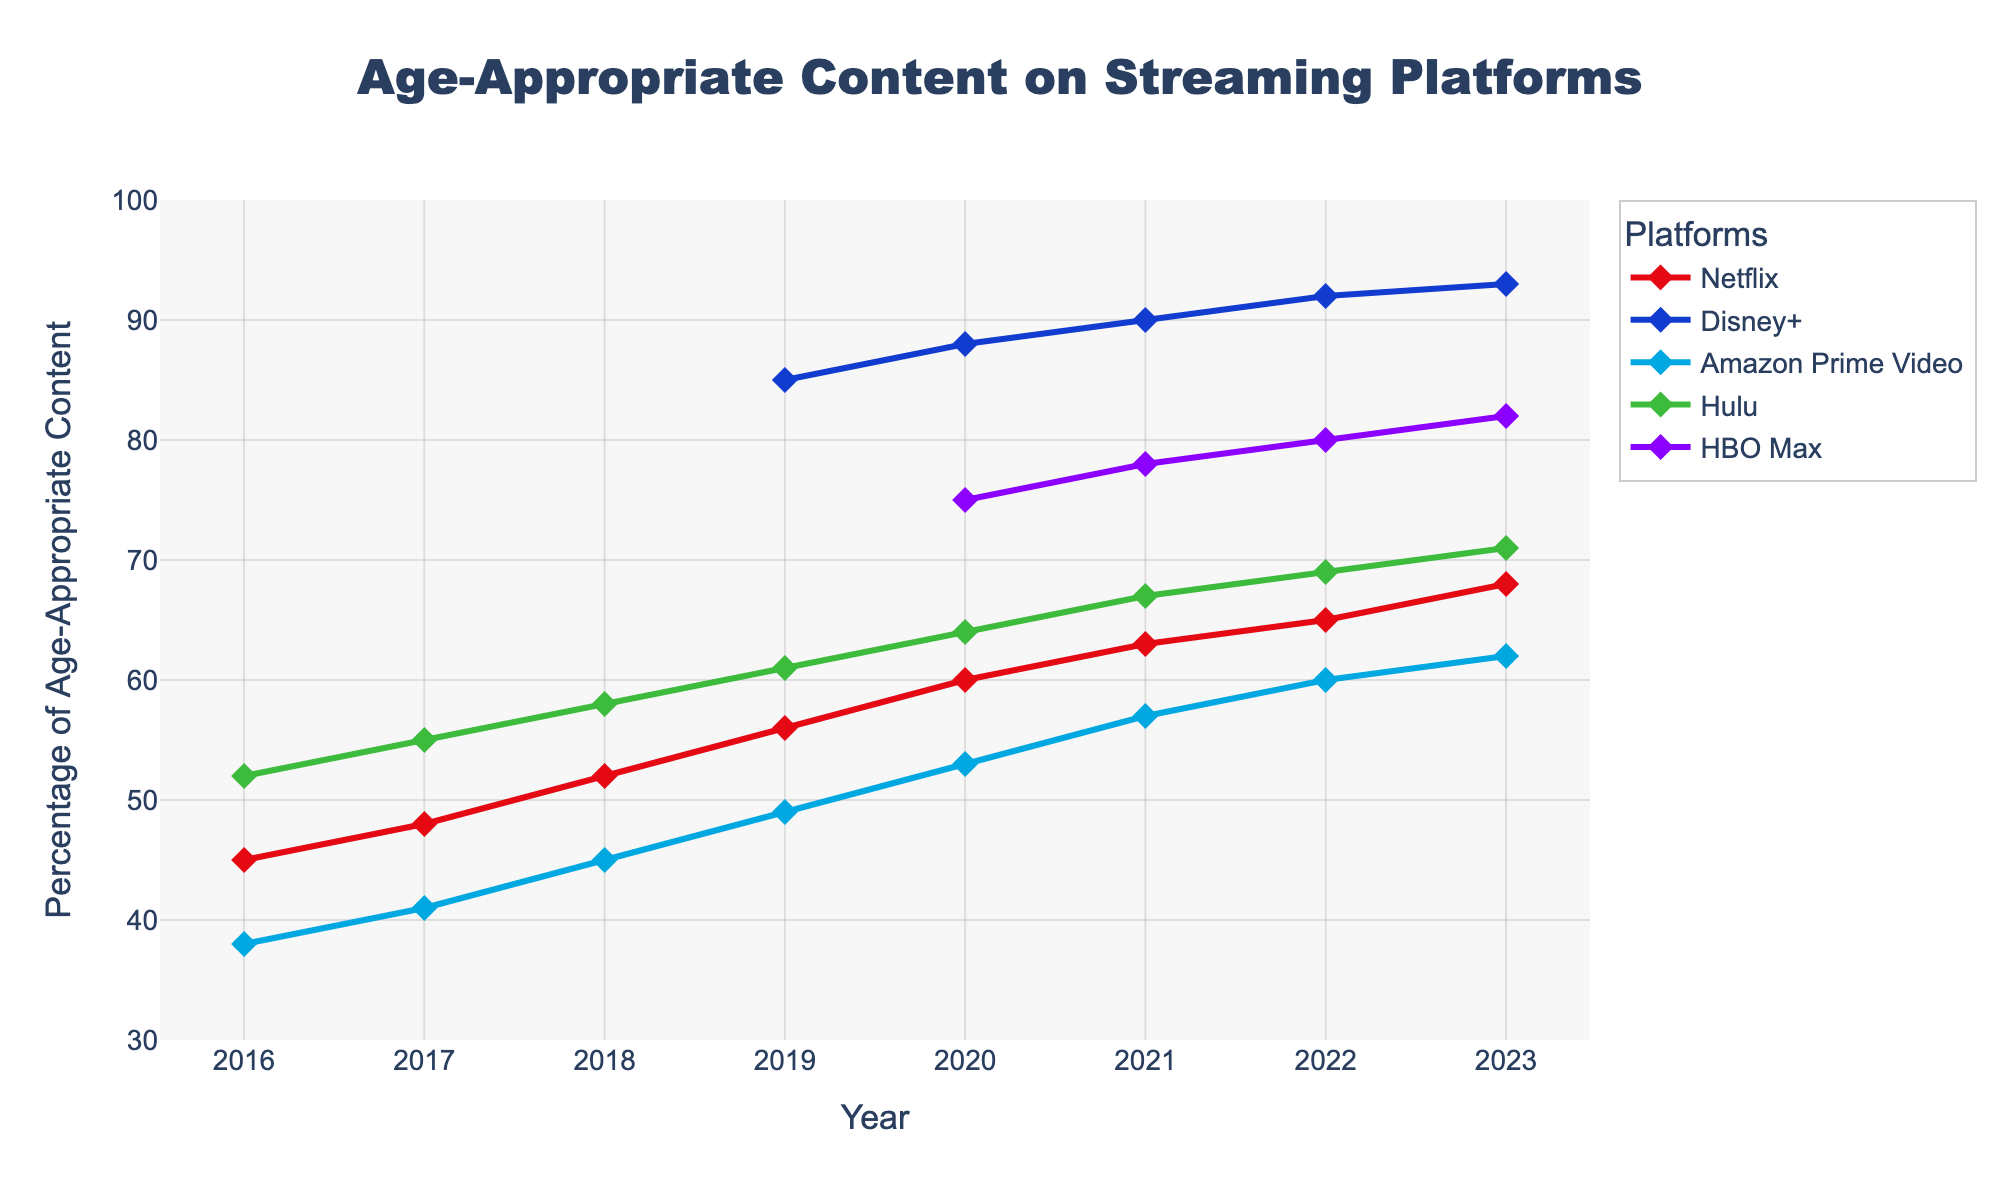Which platform showed the highest percentage of age-appropriate content in 2023? Look at the data points for each platform in 2023 and identify the highest value.
Answer: Disney+ Which platform showed a significant increase in age-appropriate content starting from 2020? Evaluate the platform lines from 2020 and look for a noticeable upward trend.
Answer: HBO Max By how many percentage points did the age-appropriate content on Hulu increase from 2016 to 2023? Subtract Hulu's 2016 percentage from its 2023 percentage (71 - 52).
Answer: 19 Which platform consistently had the lowest percentage of age-appropriate content from 2016 to 2023? Compare all platform lines and find the one that is consistently lowest.
Answer: Amazon Prime Video Between which years did Netflix see the highest percentage point increase in age-appropriate content? Calculate the difference between consecutive years and find the maximum difference for Netflix.
Answer: 2018 to 2019 How much higher was Disney+'s percentage of age-appropriate content than Netflix's in 2023? Subtract Netflix's 2023 percentage from Disney+'s 2023 percentage (93 - 68).
Answer: 25 In which year did Amazon Prime Video's age-appropriate content reach 60%? Look at Amazon Prime Video's line and identify the year it reached 60%.
Answer: 2022 What was the average percentage of age-appropriate content on Netflix from 2016 to 2023? Sum Netflix's percentages for each year and divide by the number of years (45 + 48 + 52 + 56 + 60 + 63 + 65 + 68) / 8.
Answer: 57.125 Which platform had the highest percentage of age-appropriate content in 2019, and what was that percentage? Identify the highest data point among all platforms for the year 2019.
Answer: Disney+, 85 